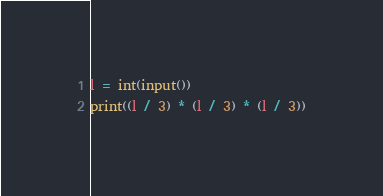Convert code to text. <code><loc_0><loc_0><loc_500><loc_500><_Python_>l = int(input())
print((l / 3) * (l / 3) * (l / 3))
</code> 